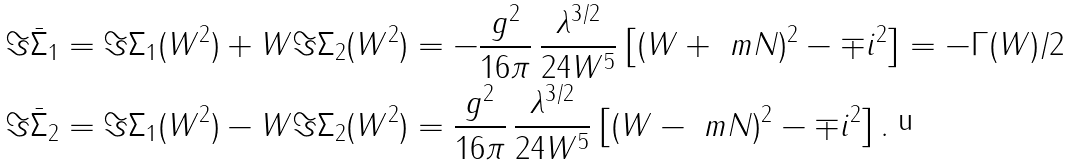Convert formula to latex. <formula><loc_0><loc_0><loc_500><loc_500>\Im \bar { \Sigma } _ { 1 } & = \Im \Sigma _ { 1 } ( W ^ { 2 } ) + W \Im \Sigma _ { 2 } ( W ^ { 2 } ) = - \frac { g ^ { 2 } } { 1 6 \pi } \, \frac { \lambda ^ { 3 / 2 } } { 2 4 W ^ { 5 } } \left [ ( W + \ m N ) ^ { 2 } - \mp i ^ { 2 } \right ] = - \Gamma ( W ) / 2 \\ \Im \bar { \Sigma } _ { 2 } & = \Im \Sigma _ { 1 } ( W ^ { 2 } ) - W \Im \Sigma _ { 2 } ( W ^ { 2 } ) = \frac { g ^ { 2 } } { 1 6 \pi } \, \frac { \lambda ^ { 3 / 2 } } { 2 4 W ^ { 5 } } \left [ ( W - \ m N ) ^ { 2 } - \mp i ^ { 2 } \right ] .</formula> 